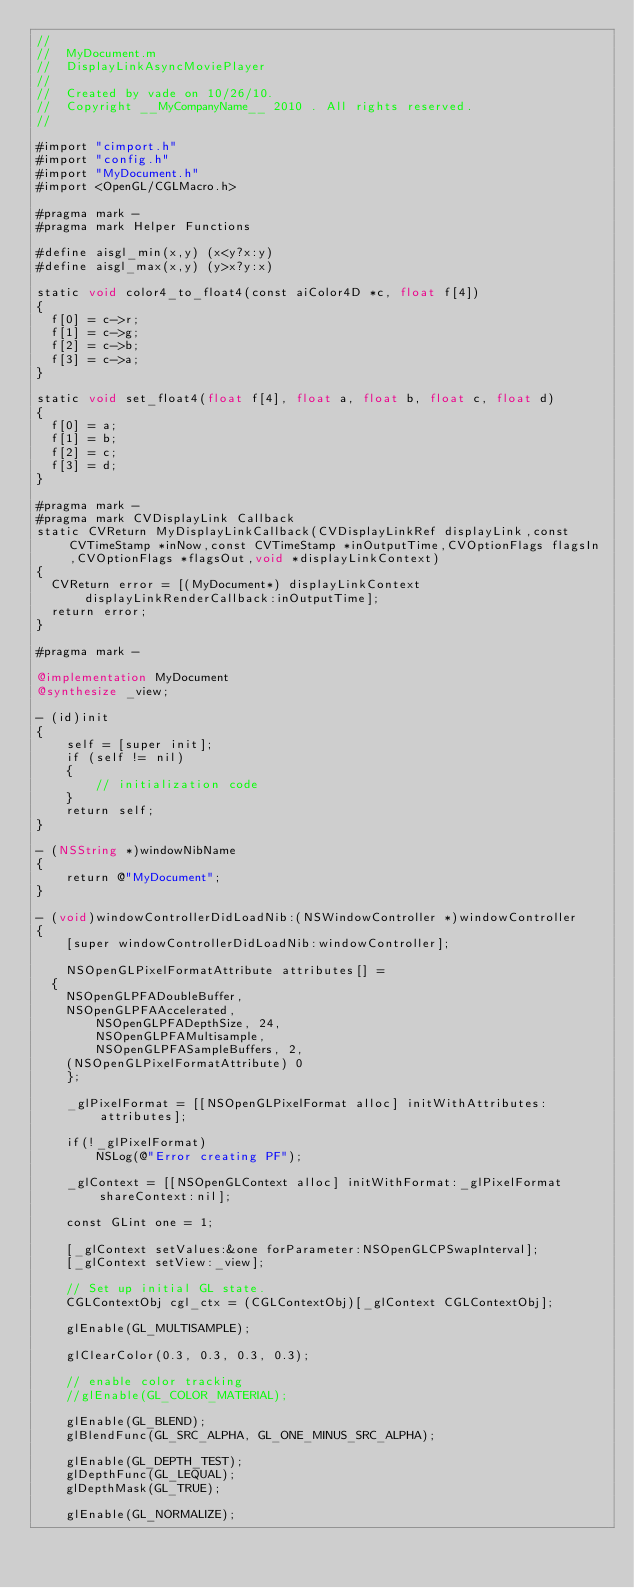Convert code to text. <code><loc_0><loc_0><loc_500><loc_500><_ObjectiveC_>//
//  MyDocument.m
//  DisplayLinkAsyncMoviePlayer
//
//  Created by vade on 10/26/10.
//  Copyright __MyCompanyName__ 2010 . All rights reserved.
//

#import "cimport.h"
#import "config.h"
#import "MyDocument.h"
#import <OpenGL/CGLMacro.h>

#pragma mark -
#pragma mark Helper Functions

#define aisgl_min(x,y) (x<y?x:y)
#define aisgl_max(x,y) (y>x?y:x)

static void color4_to_float4(const aiColor4D *c, float f[4])
{
	f[0] = c->r;
	f[1] = c->g;
	f[2] = c->b;
	f[3] = c->a;
}

static void set_float4(float f[4], float a, float b, float c, float d)
{
	f[0] = a;
	f[1] = b;
	f[2] = c;
	f[3] = d;
}

#pragma mark -
#pragma mark CVDisplayLink Callback
static CVReturn MyDisplayLinkCallback(CVDisplayLinkRef displayLink,const CVTimeStamp *inNow,const CVTimeStamp *inOutputTime,CVOptionFlags flagsIn,CVOptionFlags *flagsOut,void *displayLinkContext)
{
	CVReturn error = [(MyDocument*) displayLinkContext displayLinkRenderCallback:inOutputTime];
	return error;
}

#pragma mark -

@implementation MyDocument
@synthesize _view;

- (id)init 
{
    self = [super init];
    if (self != nil)
    {
        // initialization code
    }
    return self;
}

- (NSString *)windowNibName 
{
    return @"MyDocument";
}

- (void)windowControllerDidLoadNib:(NSWindowController *)windowController 
{
    [super windowControllerDidLoadNib:windowController];
    
    NSOpenGLPixelFormatAttribute attributes[] = 
	{
		NSOpenGLPFADoubleBuffer,
		NSOpenGLPFAAccelerated,
        NSOpenGLPFADepthSize, 24,
        NSOpenGLPFAMultisample,
        NSOpenGLPFASampleBuffers, 2,
		(NSOpenGLPixelFormatAttribute) 0
    };
    
    _glPixelFormat = [[NSOpenGLPixelFormat alloc] initWithAttributes:attributes];

    if(!_glPixelFormat)
        NSLog(@"Error creating PF");
    
    _glContext = [[NSOpenGLContext alloc] initWithFormat:_glPixelFormat shareContext:nil];
    
    const GLint one = 1;
    
    [_glContext setValues:&one forParameter:NSOpenGLCPSwapInterval];
    [_glContext setView:_view];

    // Set up initial GL state.
    CGLContextObj cgl_ctx = (CGLContextObj)[_glContext CGLContextObj];
    
    glEnable(GL_MULTISAMPLE);
    
    glClearColor(0.3, 0.3, 0.3, 0.3);

    // enable color tracking
    //glEnable(GL_COLOR_MATERIAL);

    glEnable(GL_BLEND);
    glBlendFunc(GL_SRC_ALPHA, GL_ONE_MINUS_SRC_ALPHA);
    
    glEnable(GL_DEPTH_TEST);
    glDepthFunc(GL_LEQUAL);
    glDepthMask(GL_TRUE);
    
    glEnable(GL_NORMALIZE);</code> 